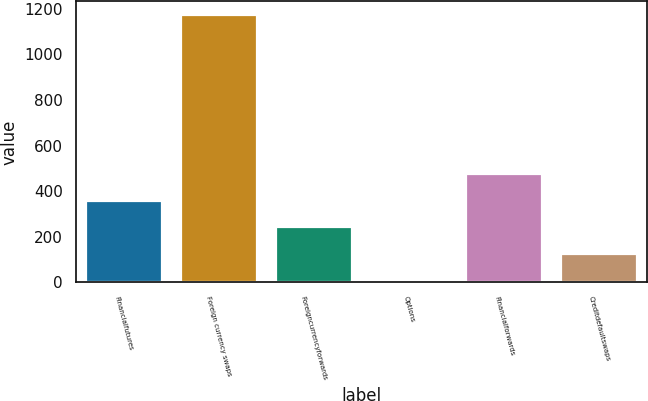<chart> <loc_0><loc_0><loc_500><loc_500><bar_chart><fcel>Financialfutures<fcel>Foreign currency swaps<fcel>Foreigncurrencyforwards<fcel>Options<fcel>Financialforwards<fcel>Creditdefaultswaps<nl><fcel>357.8<fcel>1174<fcel>241.2<fcel>8<fcel>474.4<fcel>124.6<nl></chart> 